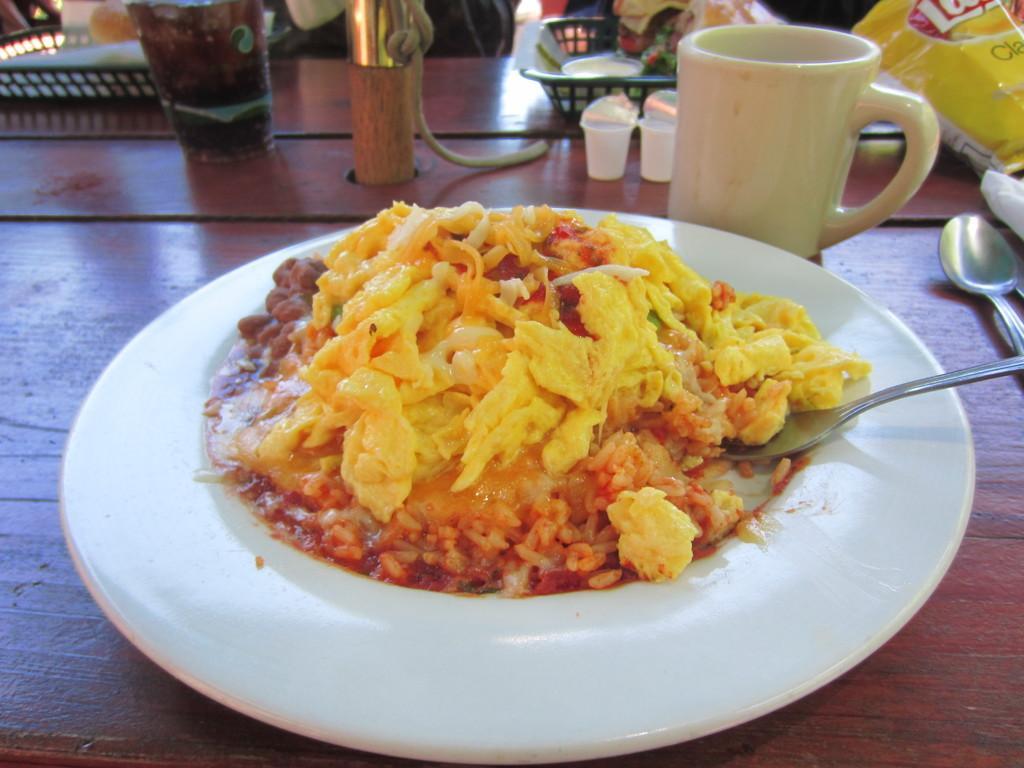Can you describe this image briefly? In this image, we can see food on the plate and there are spoons, cup, some packets, a basket, a glass with drink and some other objects on the table. 